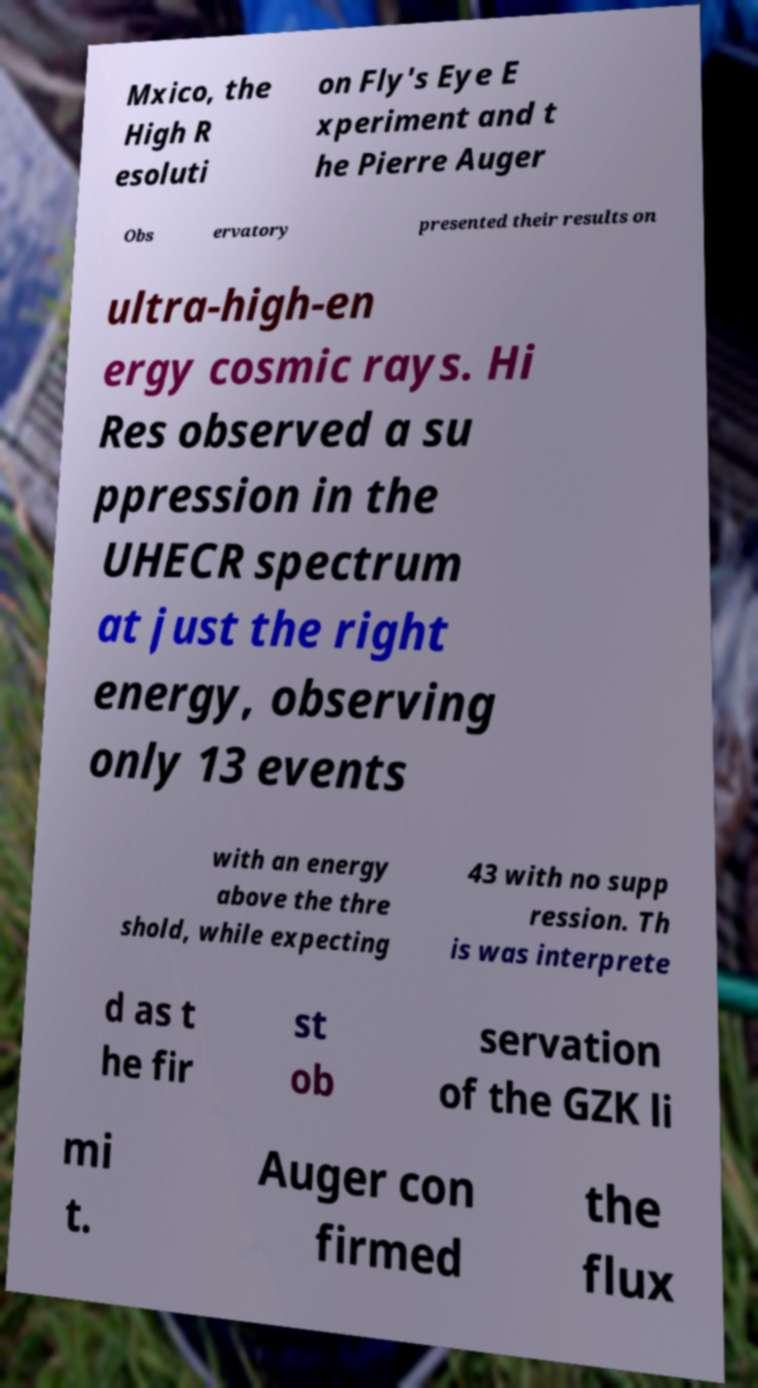What messages or text are displayed in this image? I need them in a readable, typed format. Mxico, the High R esoluti on Fly's Eye E xperiment and t he Pierre Auger Obs ervatory presented their results on ultra-high-en ergy cosmic rays. Hi Res observed a su ppression in the UHECR spectrum at just the right energy, observing only 13 events with an energy above the thre shold, while expecting 43 with no supp ression. Th is was interprete d as t he fir st ob servation of the GZK li mi t. Auger con firmed the flux 